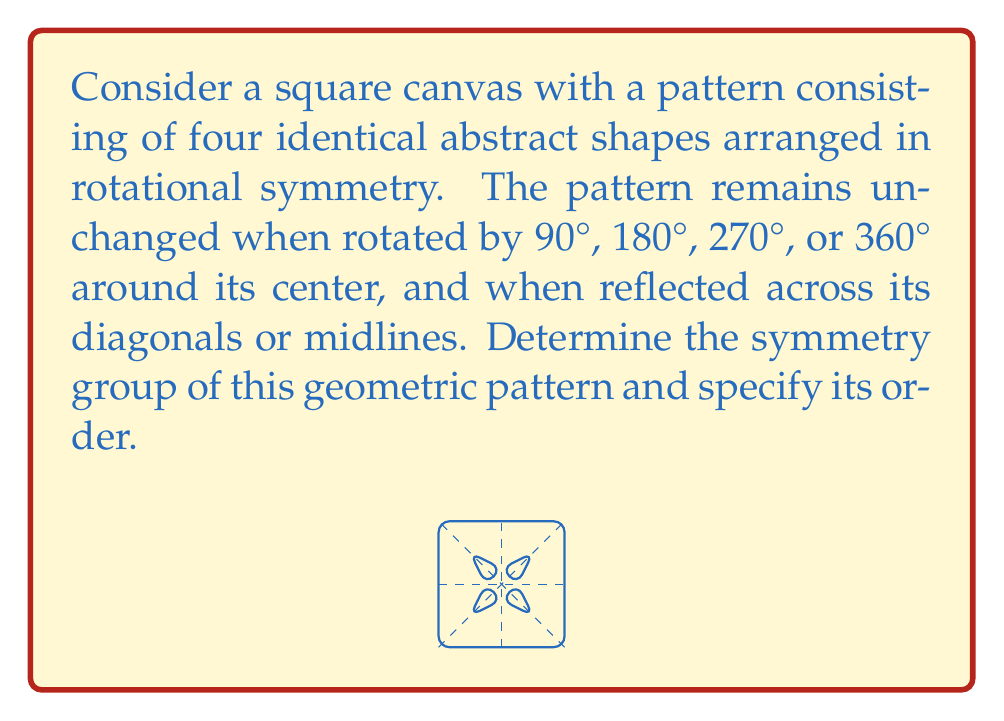Show me your answer to this math problem. To determine the symmetry group of this geometric pattern, we need to identify all the symmetry operations that leave the pattern unchanged. Let's break this down step-by-step:

1. Rotational symmetries:
   - 90° rotation (clockwise or counterclockwise)
   - 180° rotation
   - 270° rotation (equivalent to -90°)
   - 360° rotation (identity)

2. Reflection symmetries:
   - Reflection across the vertical midline
   - Reflection across the horizontal midline
   - Reflection across the diagonal from top-left to bottom-right
   - Reflection across the diagonal from top-right to bottom-left

These symmetries form a group under composition. To identify this group, we need to recognize that it contains 8 elements:
- Identity (360° rotation)
- Three rotations (90°, 180°, 270°)
- Four reflections (vertical, horizontal, and two diagonal)

This group of symmetries is isomorphic to the dihedral group $D_4$, which is the symmetry group of a square. The group $D_4$ has order 8 and can be generated by two elements: a 90° rotation and a reflection.

In group theory notation, we can write:

$$D_4 = \langle r, s \mid r^4 = s^2 = (rs)^2 = e \rangle$$

Where $r$ represents a 90° rotation, $s$ represents a reflection, and $e$ is the identity element.

For artists working with geometric patterns, understanding this symmetry group can be valuable in creating balanced and visually appealing designs. It allows for the exploration of various symmetric arrangements and transformations within a square canvas.
Answer: The symmetry group of the given geometric pattern is the dihedral group $D_4$, with order 8. 